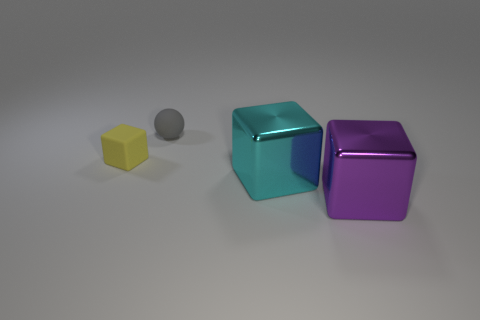Add 4 gray balls. How many objects exist? 8 Subtract all blocks. How many objects are left? 1 Add 4 small matte things. How many small matte things are left? 6 Add 2 tiny gray metallic cubes. How many tiny gray metallic cubes exist? 2 Subtract 0 yellow cylinders. How many objects are left? 4 Subtract all large objects. Subtract all tiny yellow things. How many objects are left? 1 